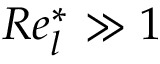<formula> <loc_0><loc_0><loc_500><loc_500>R e _ { l } ^ { * } \gg 1</formula> 